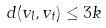<formula> <loc_0><loc_0><loc_500><loc_500>d ( v _ { l } , v _ { t } ) \leq 3 k</formula> 